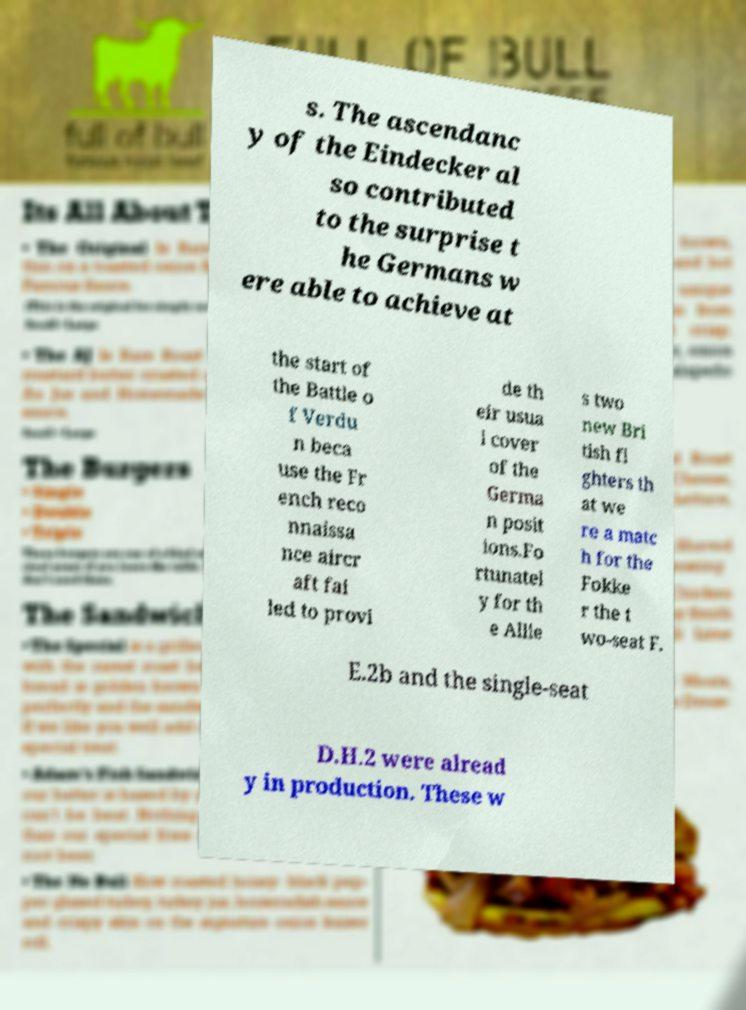Please read and relay the text visible in this image. What does it say? s. The ascendanc y of the Eindecker al so contributed to the surprise t he Germans w ere able to achieve at the start of the Battle o f Verdu n beca use the Fr ench reco nnaissa nce aircr aft fai led to provi de th eir usua l cover of the Germa n posit ions.Fo rtunatel y for th e Allie s two new Bri tish fi ghters th at we re a matc h for the Fokke r the t wo-seat F. E.2b and the single-seat D.H.2 were alread y in production. These w 